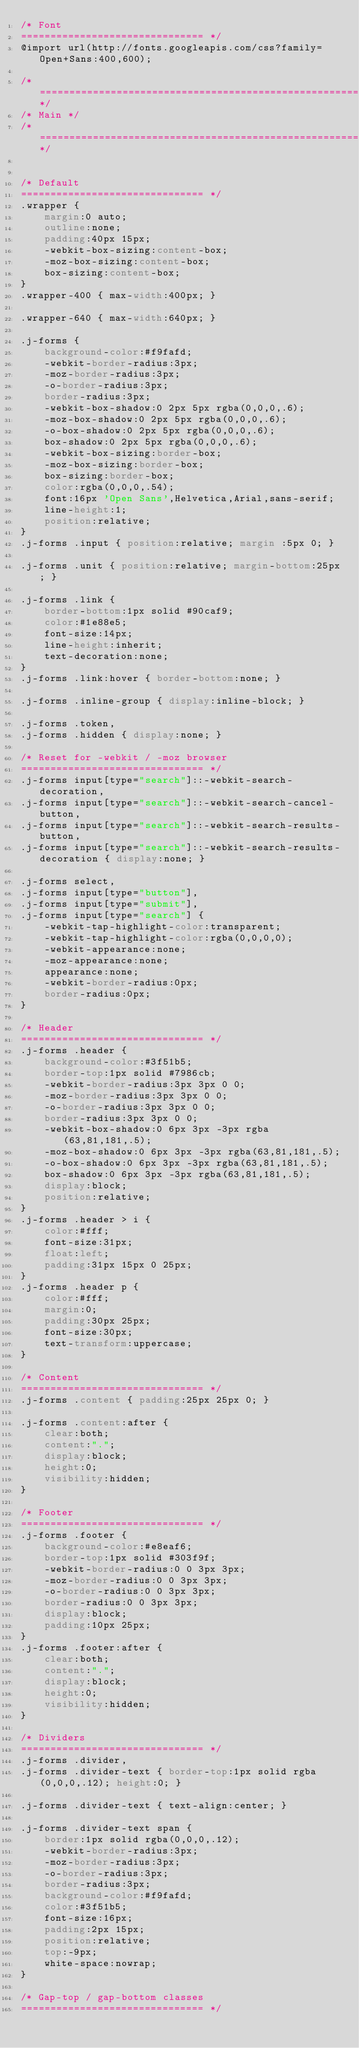Convert code to text. <code><loc_0><loc_0><loc_500><loc_500><_CSS_>/* Font
=============================== */
@import url(http://fonts.googleapis.com/css?family=Open+Sans:400,600);

/*=================================================================*/
/* Main */
/*=================================================================*/


/* Default
=============================== */
.wrapper {
	margin:0 auto;
	outline:none;
	padding:40px 15px;
	-webkit-box-sizing:content-box;
	-moz-box-sizing:content-box;
	box-sizing:content-box;
}
.wrapper-400 { max-width:400px; }

.wrapper-640 { max-width:640px; }

.j-forms {
	background-color:#f9fafd;
	-webkit-border-radius:3px;
	-moz-border-radius:3px;
	-o-border-radius:3px;
	border-radius:3px;
	-webkit-box-shadow:0 2px 5px rgba(0,0,0,.6);
	-moz-box-shadow:0 2px 5px rgba(0,0,0,.6);
	-o-box-shadow:0 2px 5px rgba(0,0,0,.6);
	box-shadow:0 2px 5px rgba(0,0,0,.6);
	-webkit-box-sizing:border-box;
	-moz-box-sizing:border-box;
	box-sizing:border-box;
	color:rgba(0,0,0,.54);
	font:16px 'Open Sans',Helvetica,Arial,sans-serif;
	line-height:1;
	position:relative;
}
.j-forms .input { position:relative; margin :5px 0; }

.j-forms .unit { position:relative; margin-bottom:25px; }

.j-forms .link {
	border-bottom:1px solid #90caf9;
	color:#1e88e5;
	font-size:14px;
	line-height:inherit;
	text-decoration:none;
}
.j-forms .link:hover { border-bottom:none; }

.j-forms .inline-group { display:inline-block; }

.j-forms .token,
.j-forms .hidden { display:none; }

/* Reset for -webkit / -moz browser
=============================== */
.j-forms input[type="search"]::-webkit-search-decoration,
.j-forms input[type="search"]::-webkit-search-cancel-button,
.j-forms input[type="search"]::-webkit-search-results-button,
.j-forms input[type="search"]::-webkit-search-results-decoration { display:none; }

.j-forms select,
.j-forms input[type="button"],
.j-forms input[type="submit"],
.j-forms input[type="search"] {
	-webkit-tap-highlight-color:transparent;
	-webkit-tap-highlight-color:rgba(0,0,0,0);
	-webkit-appearance:none;
	-moz-appearance:none;
	appearance:none;
	-webkit-border-radius:0px;
	border-radius:0px;
}

/* Header
=============================== */
.j-forms .header {
	background-color:#3f51b5;
	border-top:1px solid #7986cb;
	-webkit-border-radius:3px 3px 0 0;
	-moz-border-radius:3px 3px 0 0;
	-o-border-radius:3px 3px 0 0;
	border-radius:3px 3px 0 0;
	-webkit-box-shadow:0 6px 3px -3px rgba(63,81,181,.5);
	-moz-box-shadow:0 6px 3px -3px rgba(63,81,181,.5);
	-o-box-shadow:0 6px 3px -3px rgba(63,81,181,.5);
	box-shadow:0 6px 3px -3px rgba(63,81,181,.5);
	display:block;
	position:relative;
}
.j-forms .header > i {
	color:#fff;
	font-size:31px;
	float:left;
	padding:31px 15px 0 25px;
}
.j-forms .header p {
	color:#fff;
	margin:0;
	padding:30px 25px;
	font-size:30px;
	text-transform:uppercase;
}

/* Content
=============================== */
.j-forms .content { padding:25px 25px 0; }

.j-forms .content:after {
	clear:both;
	content:".";
	display:block;
	height:0;
	visibility:hidden;
}

/* Footer
=============================== */
.j-forms .footer {
	background-color:#e8eaf6;
	border-top:1px solid #303f9f;
	-webkit-border-radius:0 0 3px 3px;
	-moz-border-radius:0 0 3px 3px;
	-o-border-radius:0 0 3px 3px;
	border-radius:0 0 3px 3px;
	display:block;
	padding:10px 25px;
}
.j-forms .footer:after {
	clear:both;
	content:".";
	display:block;
	height:0;
	visibility:hidden;
}

/* Dividers
=============================== */
.j-forms .divider,
.j-forms .divider-text { border-top:1px solid rgba(0,0,0,.12); height:0; }

.j-forms .divider-text { text-align:center; }

.j-forms .divider-text span {
	border:1px solid rgba(0,0,0,.12);
	-webkit-border-radius:3px;
	-moz-border-radius:3px;
	-o-border-radius:3px;
	border-radius:3px;
	background-color:#f9fafd;
	color:#3f51b5;
	font-size:16px;
	padding:2px 15px;
	position:relative;
	top:-9px;
	white-space:nowrap;
}

/* Gap-top / gap-bottom classes
=============================== */</code> 